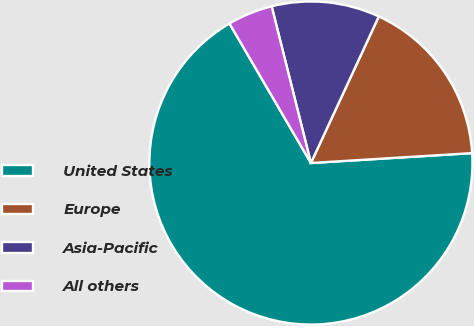<chart> <loc_0><loc_0><loc_500><loc_500><pie_chart><fcel>United States<fcel>Europe<fcel>Asia-Pacific<fcel>All others<nl><fcel>67.57%<fcel>17.12%<fcel>10.81%<fcel>4.5%<nl></chart> 